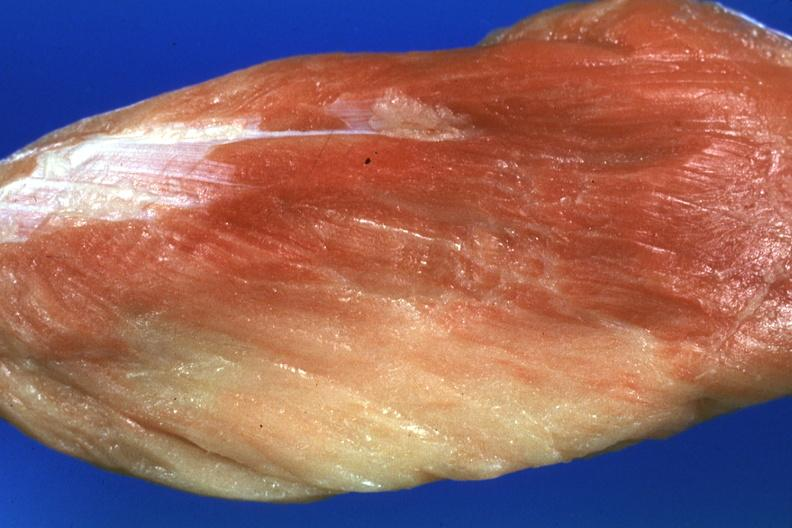does this image show close-up with some red muscle remaining?
Answer the question using a single word or phrase. Yes 